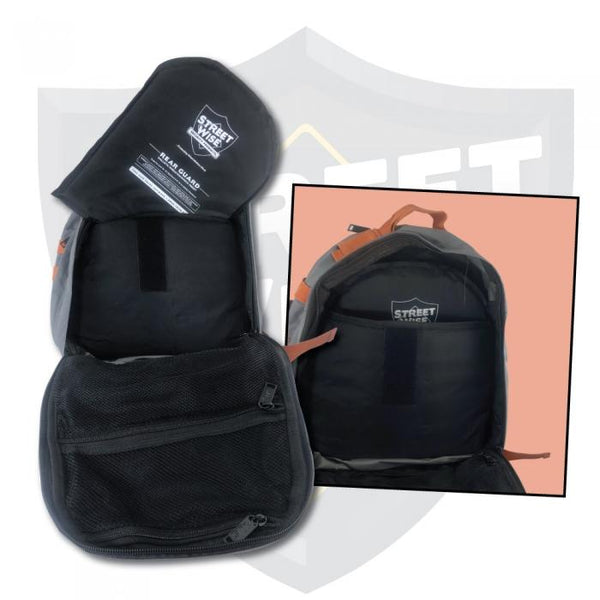Create an imaginary adventure scenario that could utilize all the current features of this backpack. Imagine embarking on an epic cross-country motorcycling adventure. You start the journey at sunrise, with the reflective elements of your backpack ensuring high visibility on early morning roads. As the day warms up and you take breaks along scenic routes, you appreciate the ventilated mesh compartment to store your helmet and jacket, keeping them dry and aired out. As dusk falls, the enhanced visibility features become crucial again, making sure you're seen by other vehicles. The trip involves impromptu hikes to explore hidden trails, where the backpack's versatile storage compartments come in handy for carrying water, snacks, and other hiking essentials, ensuring you're well-prepared for every part of your journey. 